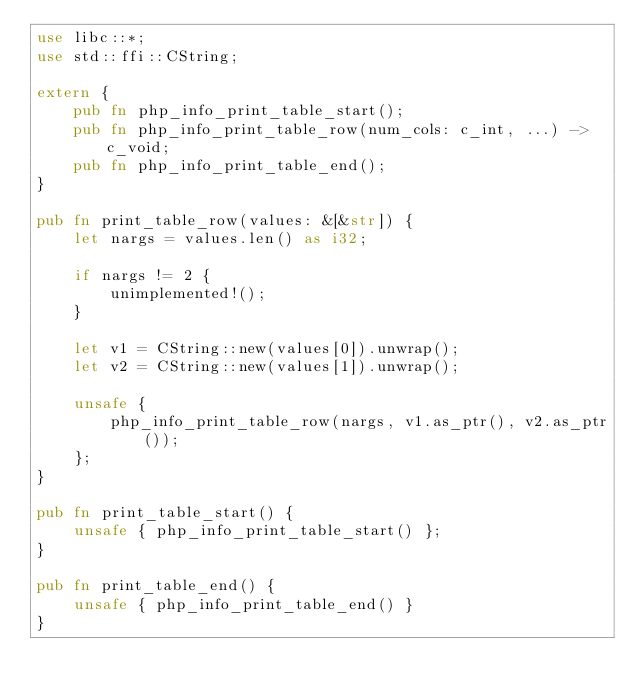<code> <loc_0><loc_0><loc_500><loc_500><_Rust_>use libc::*;
use std::ffi::CString;

extern {
    pub fn php_info_print_table_start();
    pub fn php_info_print_table_row(num_cols: c_int, ...) -> c_void;
    pub fn php_info_print_table_end();
}

pub fn print_table_row(values: &[&str]) {
    let nargs = values.len() as i32;

    if nargs != 2 {
        unimplemented!();
    }

    let v1 = CString::new(values[0]).unwrap();
    let v2 = CString::new(values[1]).unwrap();

    unsafe {
        php_info_print_table_row(nargs, v1.as_ptr(), v2.as_ptr());
    };
}

pub fn print_table_start() {
    unsafe { php_info_print_table_start() };
}

pub fn print_table_end() {
    unsafe { php_info_print_table_end() }
}</code> 